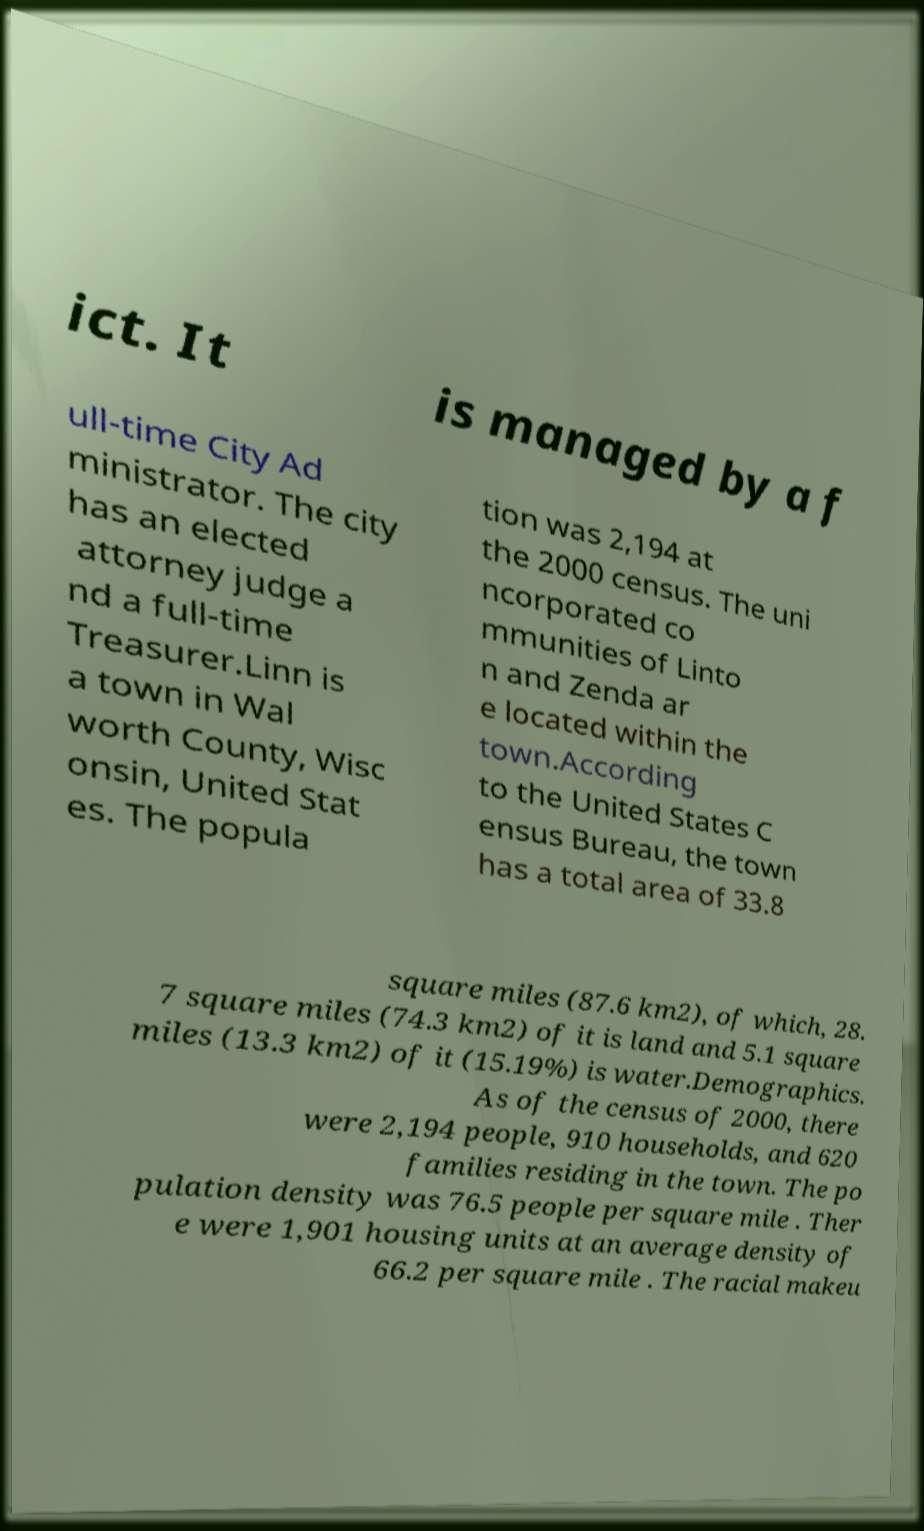Can you accurately transcribe the text from the provided image for me? ict. It is managed by a f ull-time City Ad ministrator. The city has an elected attorney judge a nd a full-time Treasurer.Linn is a town in Wal worth County, Wisc onsin, United Stat es. The popula tion was 2,194 at the 2000 census. The uni ncorporated co mmunities of Linto n and Zenda ar e located within the town.According to the United States C ensus Bureau, the town has a total area of 33.8 square miles (87.6 km2), of which, 28. 7 square miles (74.3 km2) of it is land and 5.1 square miles (13.3 km2) of it (15.19%) is water.Demographics. As of the census of 2000, there were 2,194 people, 910 households, and 620 families residing in the town. The po pulation density was 76.5 people per square mile . Ther e were 1,901 housing units at an average density of 66.2 per square mile . The racial makeu 